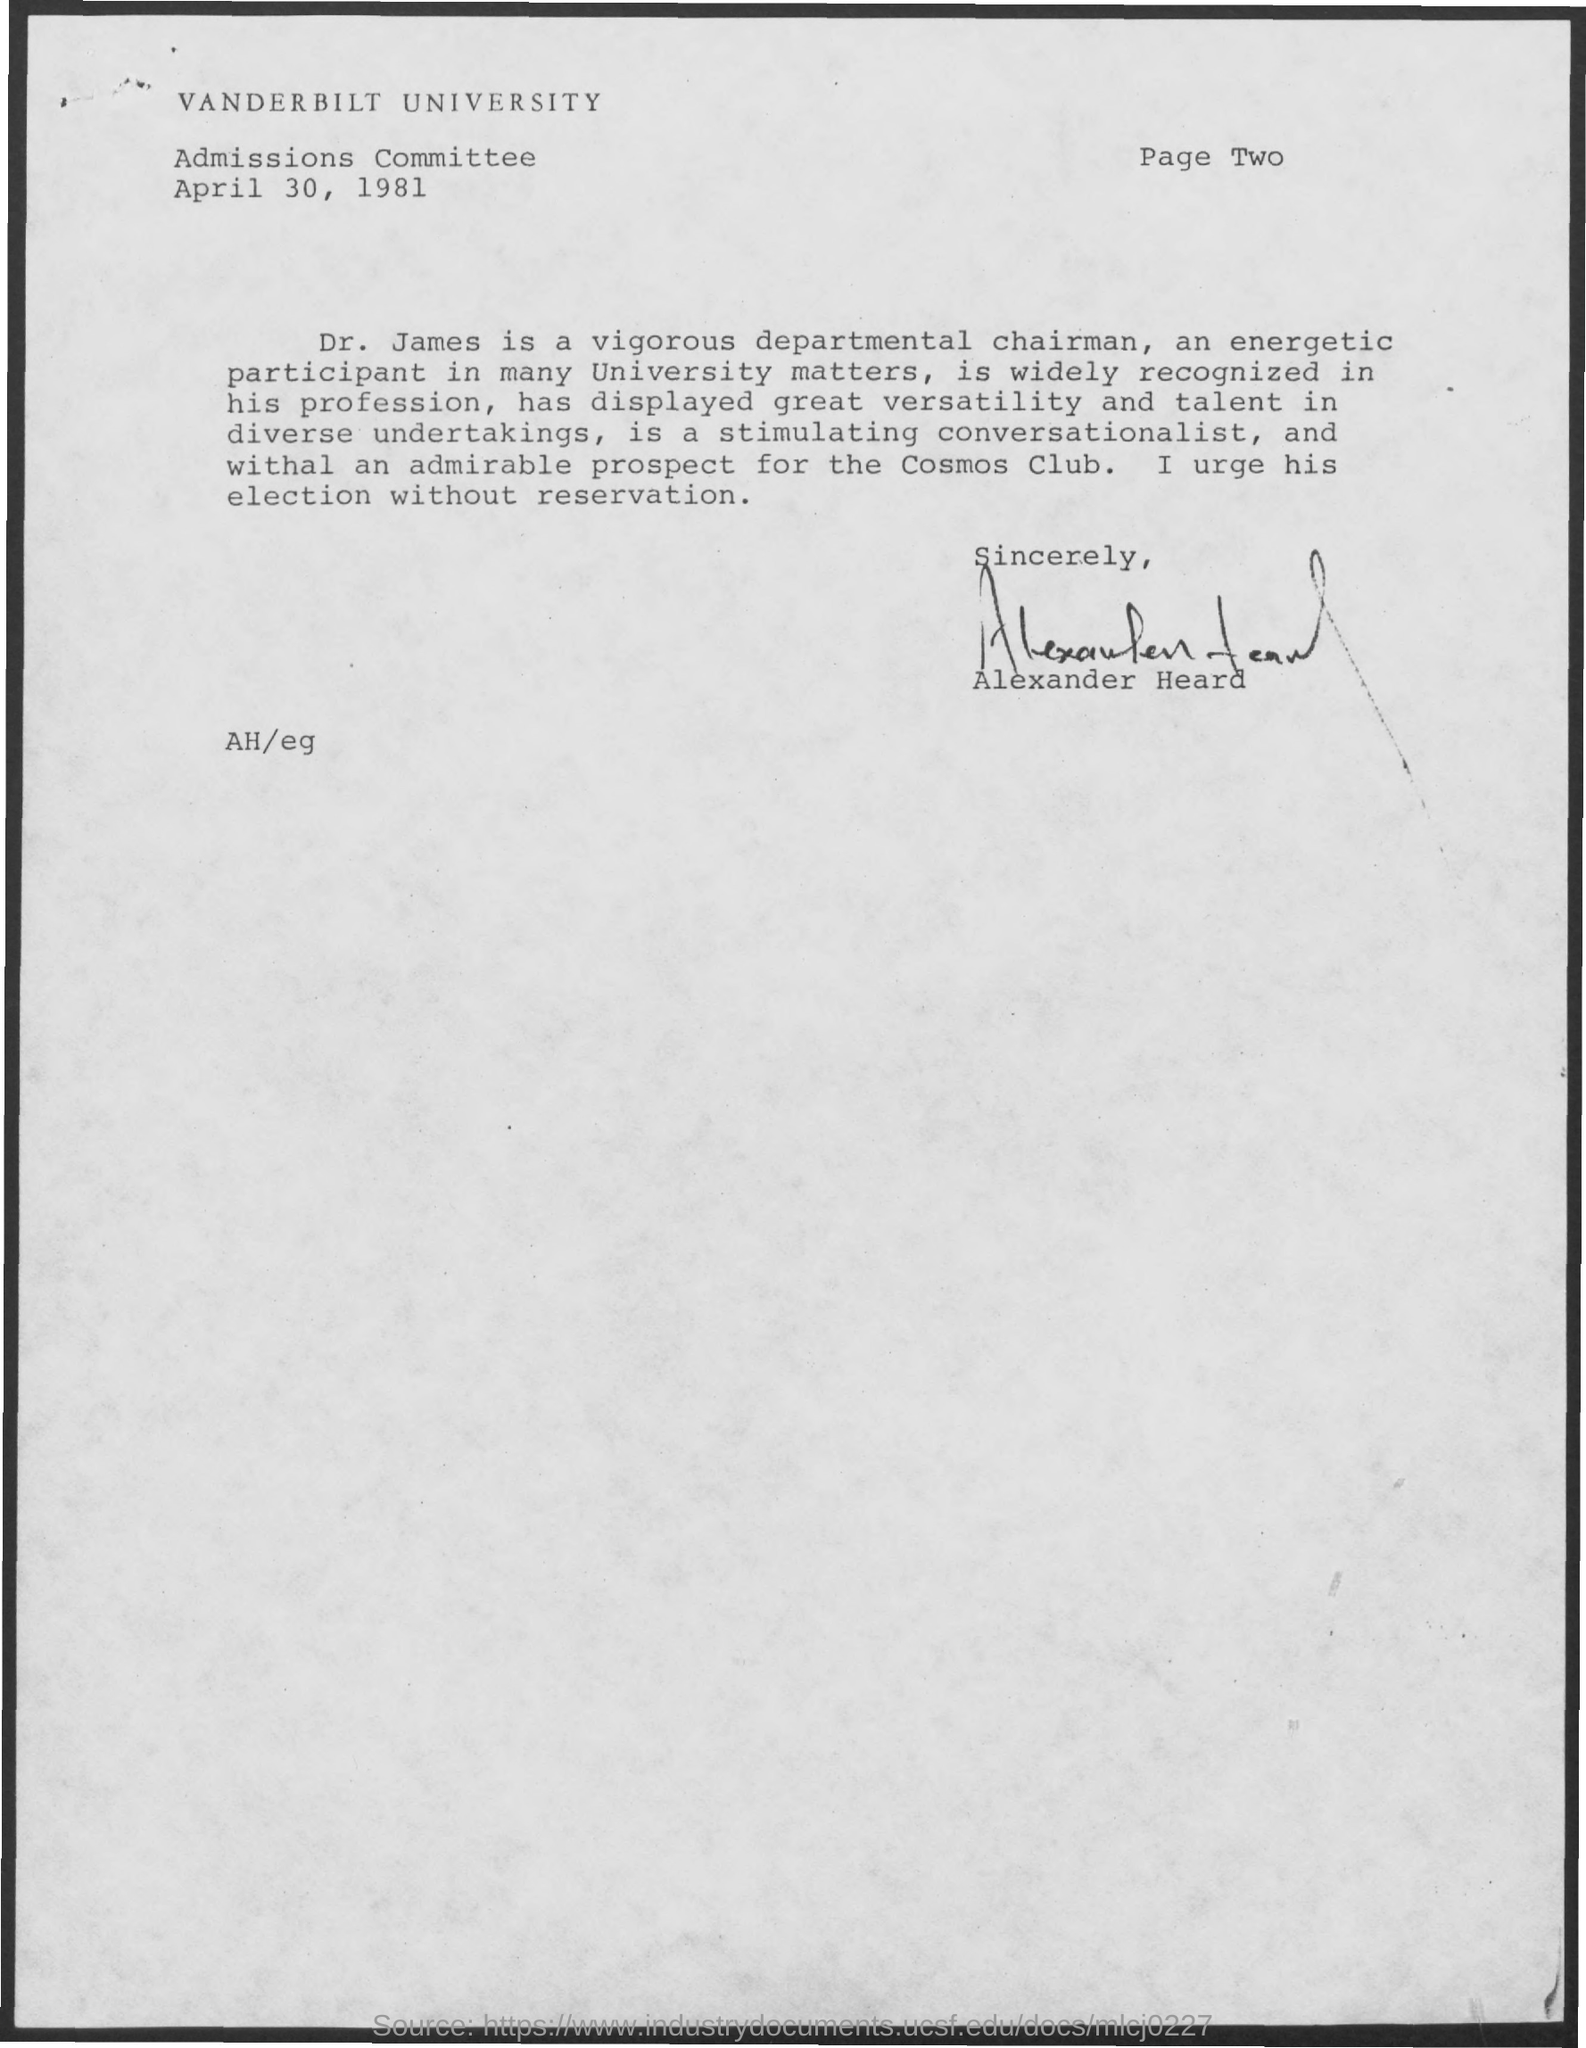What is the University Name ?
Keep it short and to the point. VANDERBILT UNIVERSITY. What is the Page Number ?
Give a very brief answer. Page Two. When is the Memorandum dated on ?
Offer a very short reply. April 30, 1981. 